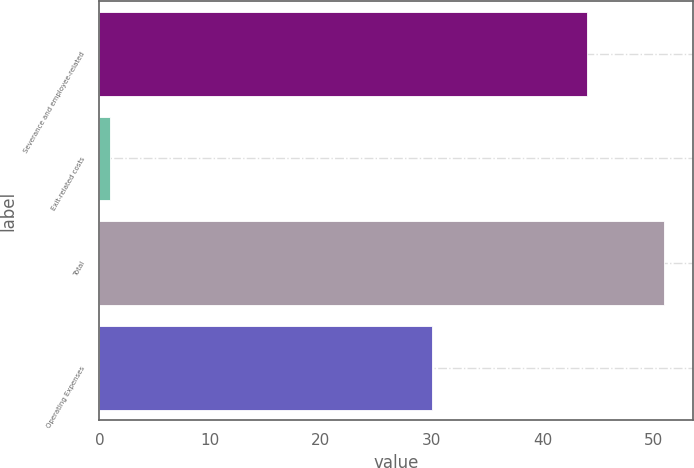Convert chart to OTSL. <chart><loc_0><loc_0><loc_500><loc_500><bar_chart><fcel>Severance and employee-related<fcel>Exit-related costs<fcel>Total<fcel>Operating Expenses<nl><fcel>44<fcel>1<fcel>51<fcel>30<nl></chart> 